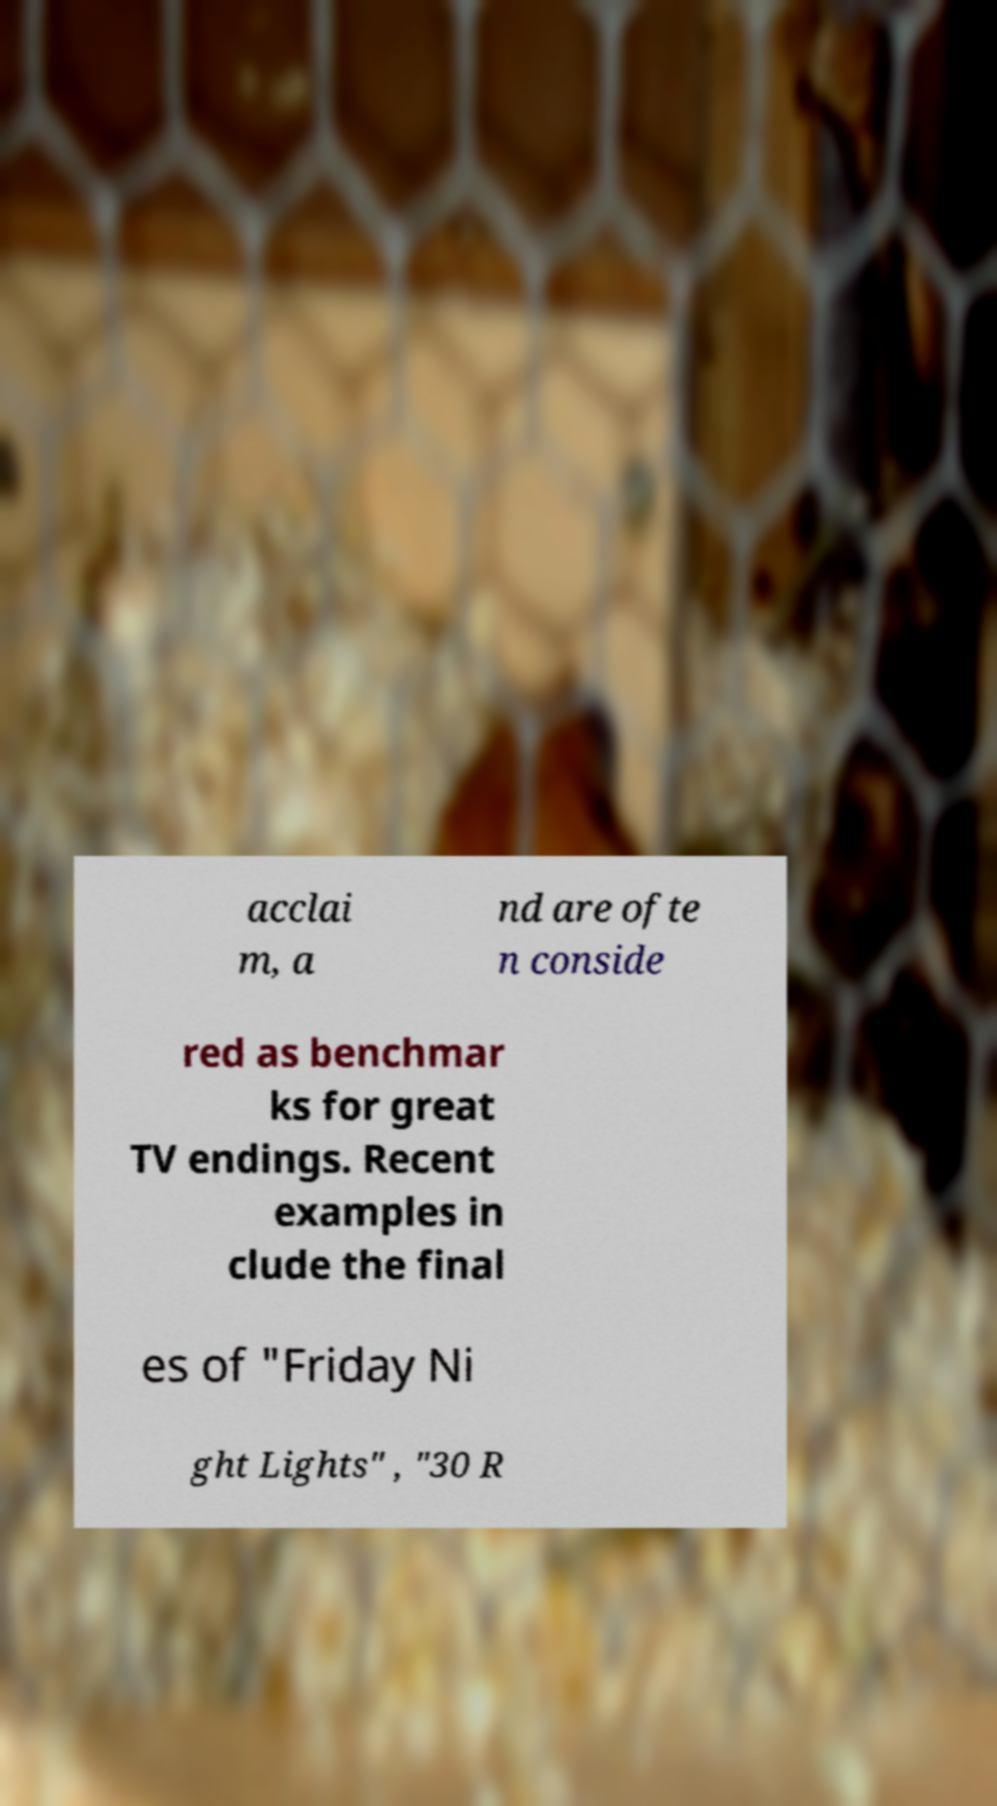Please identify and transcribe the text found in this image. acclai m, a nd are ofte n conside red as benchmar ks for great TV endings. Recent examples in clude the final es of "Friday Ni ght Lights" , "30 R 